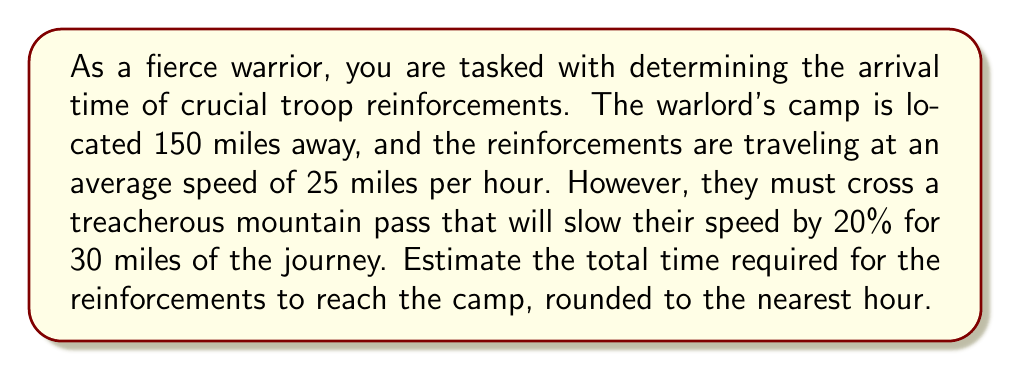Help me with this question. Let's break this problem down into steps:

1. Calculate the distance traveled at normal speed:
   Total distance = 150 miles
   Mountain pass distance = 30 miles
   Normal speed distance = 150 - 30 = 120 miles

2. Calculate the time taken for the normal speed portion:
   Time = Distance / Speed
   $t_1 = \frac{120 \text{ miles}}{25 \text{ miles/hour}} = 4.8 \text{ hours}$

3. Calculate the reduced speed in the mountain pass:
   Reduced speed = Normal speed × (1 - 0.20)
   $\text{Reduced speed} = 25 \times 0.8 = 20 \text{ miles/hour}$

4. Calculate the time taken for the mountain pass portion:
   $t_2 = \frac{30 \text{ miles}}{20 \text{ miles/hour}} = 1.5 \text{ hours}$

5. Sum up the total time:
   Total time = Time for normal speed + Time for mountain pass
   $t_{\text{total}} = t_1 + t_2 = 4.8 + 1.5 = 6.3 \text{ hours}$

6. Round to the nearest hour:
   6.3 hours rounds to 6 hours
Answer: The estimated time for the troop reinforcements to arrive is 6 hours. 